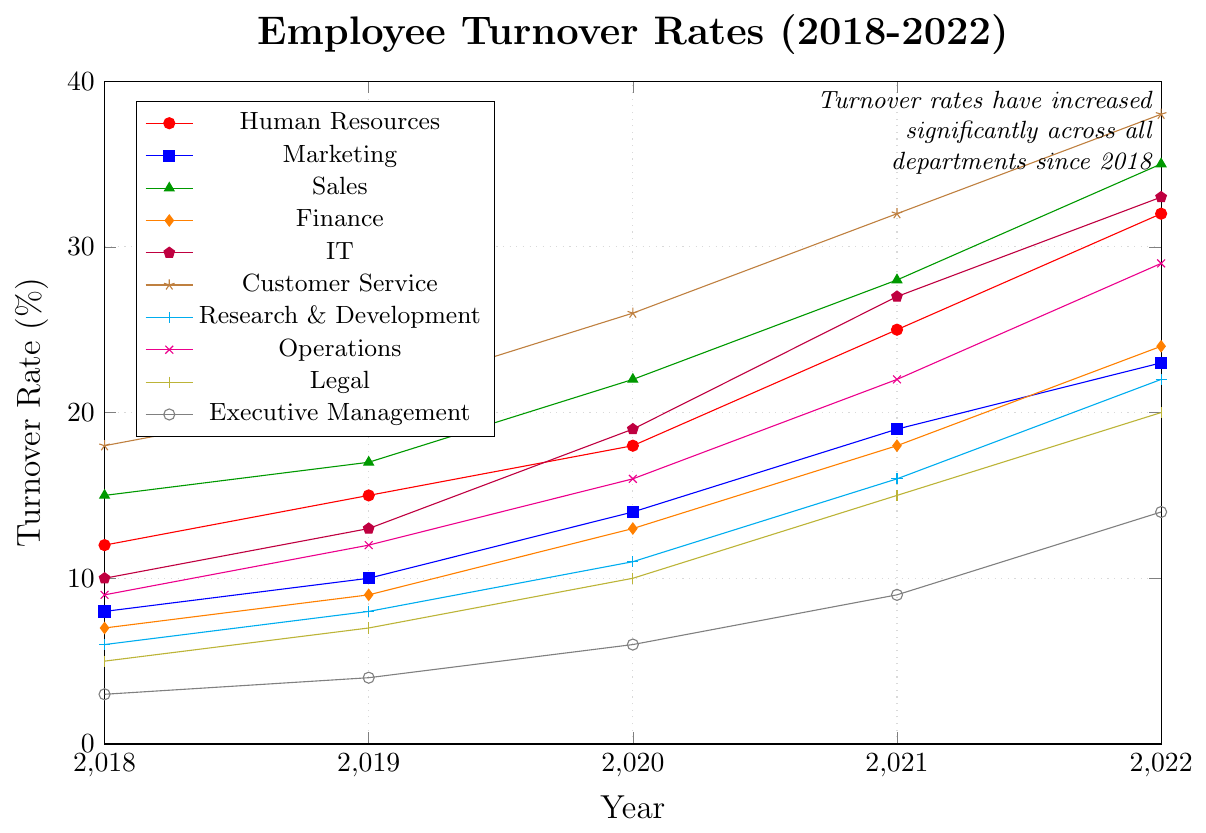What was the turnover rate for the Marketing department in 2019? Look at the line corresponding to the Marketing department and find the value at the year 2019.
Answer: 10% Which department had the highest turnover rate in 2022? The line with the maximum y-value in 2022 will show the highest turnover rate. This is the Customer Service department.
Answer: Customer Service What is the difference in turnover rates between the Sales and Finance departments in 2022? Check the turnover rates for Sales (35%) and Finance (24%) in 2022 and subtract the latter from the former. 35% - 24% = 11%.
Answer: 11% Which department had the smallest increase in turnover rates from 2018 to 2022? Calculate the increase in turnover rates for each department and find the minimum. Executive Management: 14% - 3% = 11% (minimum)
Answer: Executive Management Did the IT department have a greater turnover rate increase over the five years compared to the Human Resources department? Calculate the difference for both IT (33% - 10% = 23%) and HR (32% - 12% = 20%) and compare them.
Answer: Yes In which year did the turnover rate for Customer Service hit 32%? Trace the Customer Service line and check the year corresponding to 32%.
Answer: 2021 How much did the turnover rate in Research & Development increase from 2019 to 2021? Subtract the 2019 rate from the 2021 rate for Research & Development. 16% - 8% = 8%.
Answer: 8% What is the average turnover rate in 2022 across all departments? Sum the 2022 rates across all departments and divide by the number of departments (10). (32+23+35+24+33+38+22+29+20+14)/10 = 27%.4
Answer: 27%.4 Which two departments had identical turnover rates at any point in the last five years? Check the turnover rates across years for identical values. In 2019, Finance and Legal both had a turnover rate of 7%.
Answer: Finance and Legal (2019) What trend can be observed in graphical terms for the Human Resources department from 2018 to 2022? The line for Human Resources shows a consistent upward trajectory, indicating a steady increase in turnover rates over the years.
Answer: Steady increase 